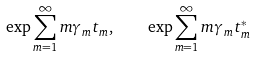Convert formula to latex. <formula><loc_0><loc_0><loc_500><loc_500>\exp \sum _ { m = 1 } ^ { \infty } m \gamma _ { m } t _ { m } , \quad \exp \sum _ { m = 1 } ^ { \infty } m \gamma _ { m } t _ { m } ^ { * }</formula> 